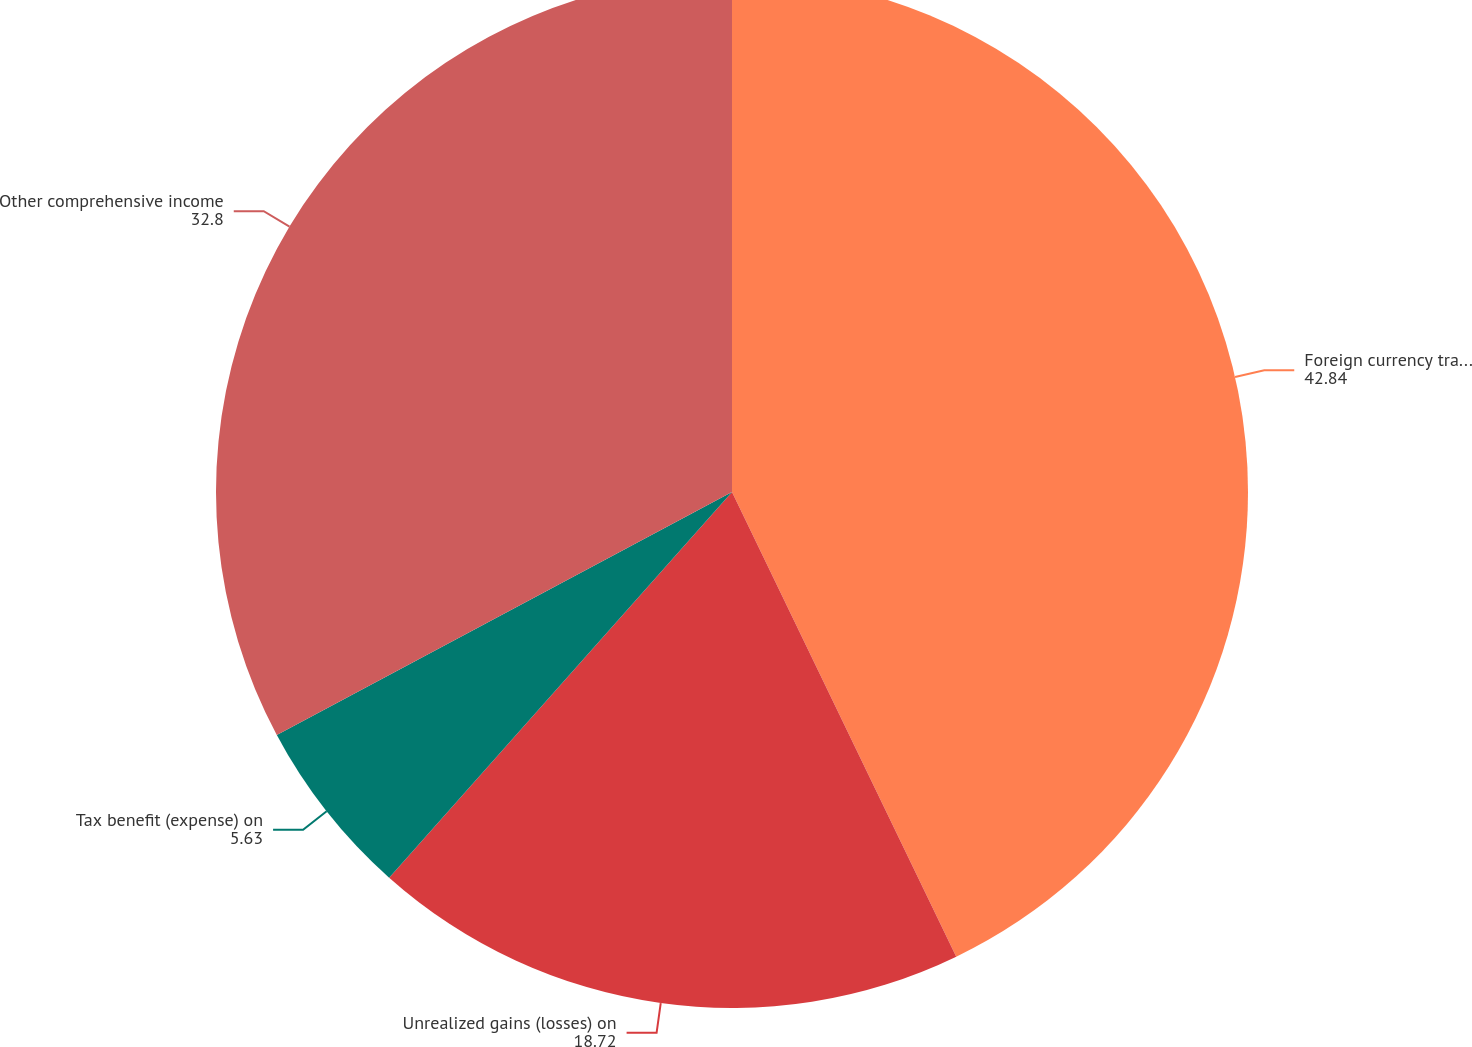Convert chart to OTSL. <chart><loc_0><loc_0><loc_500><loc_500><pie_chart><fcel>Foreign currency translation<fcel>Unrealized gains (losses) on<fcel>Tax benefit (expense) on<fcel>Other comprehensive income<nl><fcel>42.84%<fcel>18.72%<fcel>5.63%<fcel>32.8%<nl></chart> 